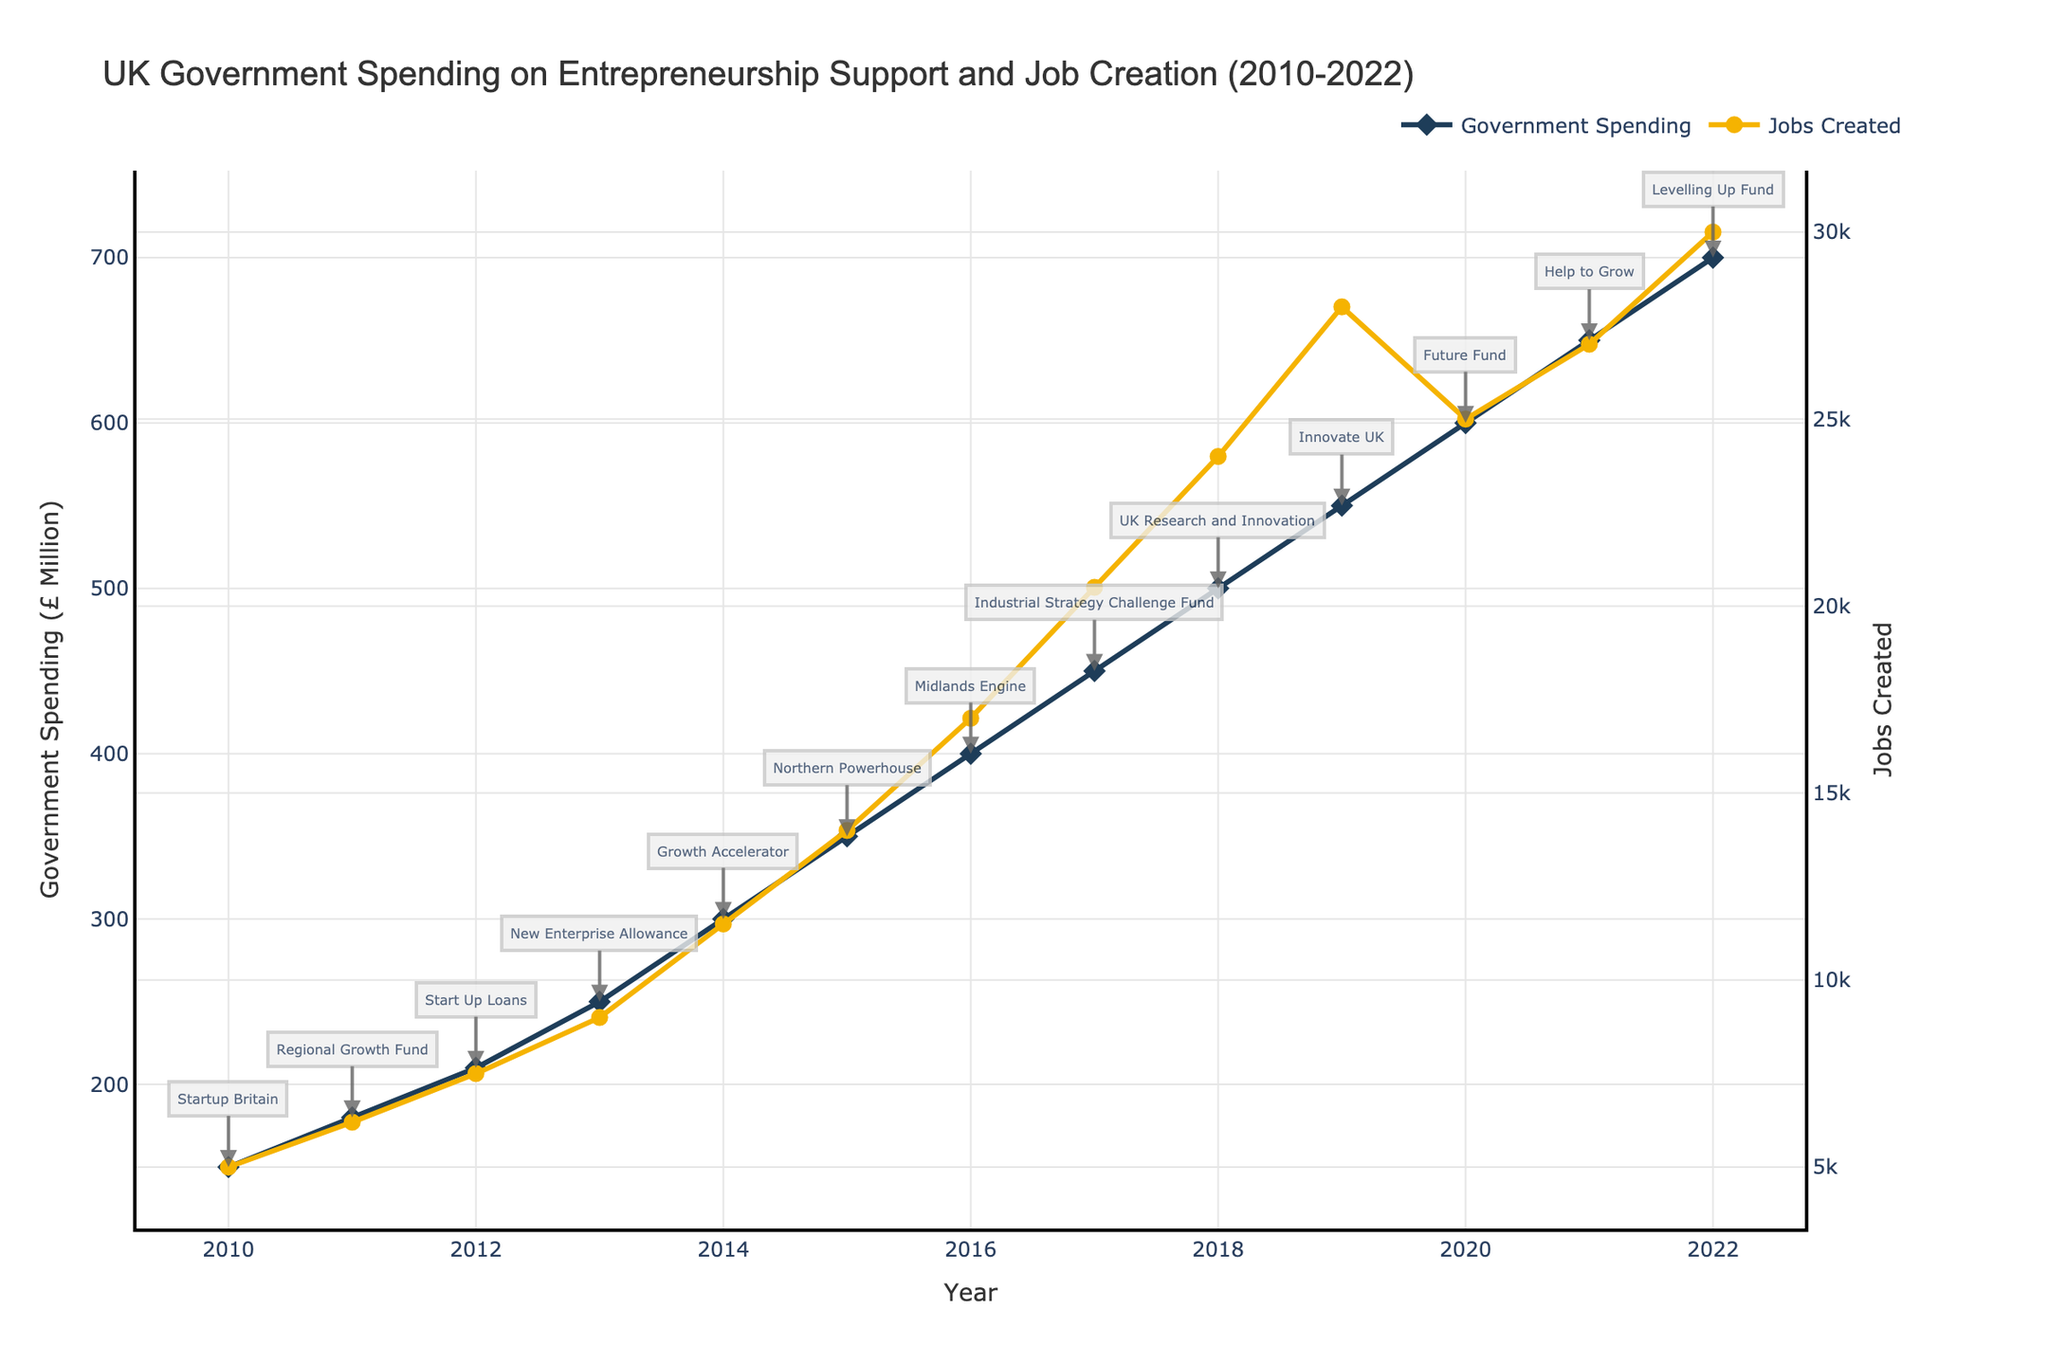What is the trend in government spending on entrepreneurship support programs from 2010 to 2022? First, observe the line representing government spending. There is a clear upward trend in government spending from £150 million in 2010 to £700 million in 2022.
Answer: Upward trend How did the number of jobs created change between 2010 and 2022? Look at the line representing jobs created. It shows an increasing trend from 5000 jobs in 2010 to 30000 jobs in 2022.
Answer: Increasing trend Between 2016 and 2018, how much did government spending increase? Government spending in 2016 was £400 million, and in 2018 it was £500 million. The increase is £500 million - £400 million = £100 million.
Answer: £100 million Which program, mentioned in the figure, is associated with the highest government spending? Levelling Up Fund in 2022 is associated with the highest government spending of £700 million.
Answer: Levelling Up Fund In which year did the UK government spend £350 million on entrepreneurship support programs, and how many jobs were created that year? In 2015, the government spent £350 million, and 14000 jobs were created.
Answer: 2015, 14000 jobs How does the number of jobs created in 2020 compare to 2021? In 2020, 25000 jobs were created, and in 2021, 27000 jobs were created. Comparing the two, 27000 (2021) - 25000 (2020) = 2000 more jobs were created in 2021.
Answer: 2000 more jobs in 2021 What is the average annual government spending on entrepreneurship support programs from 2010 to 2022? Sum the government spending from each year and divide by the number of years: (£150M + £180M + £210M + £250M + £300M + £350M + £400M + £450M + £500M + £550M + £600M + £650M + £700M) / 13 ≈ £423.08M.
Answer: £423.08 million By how much did the number of jobs created increase from 2010 to 2019? The number of jobs created increased from 5000 in 2010 to 28000 in 2019, giving an increase of 28000 - 5000 = 23000 jobs.
Answer: 23000 jobs Which color represents the line for government spending, and which represents the line for jobs created? The line for government spending is colored dark blue, and the line for jobs created is yellow.
Answer: Dark blue for government spending, yellow for jobs created 